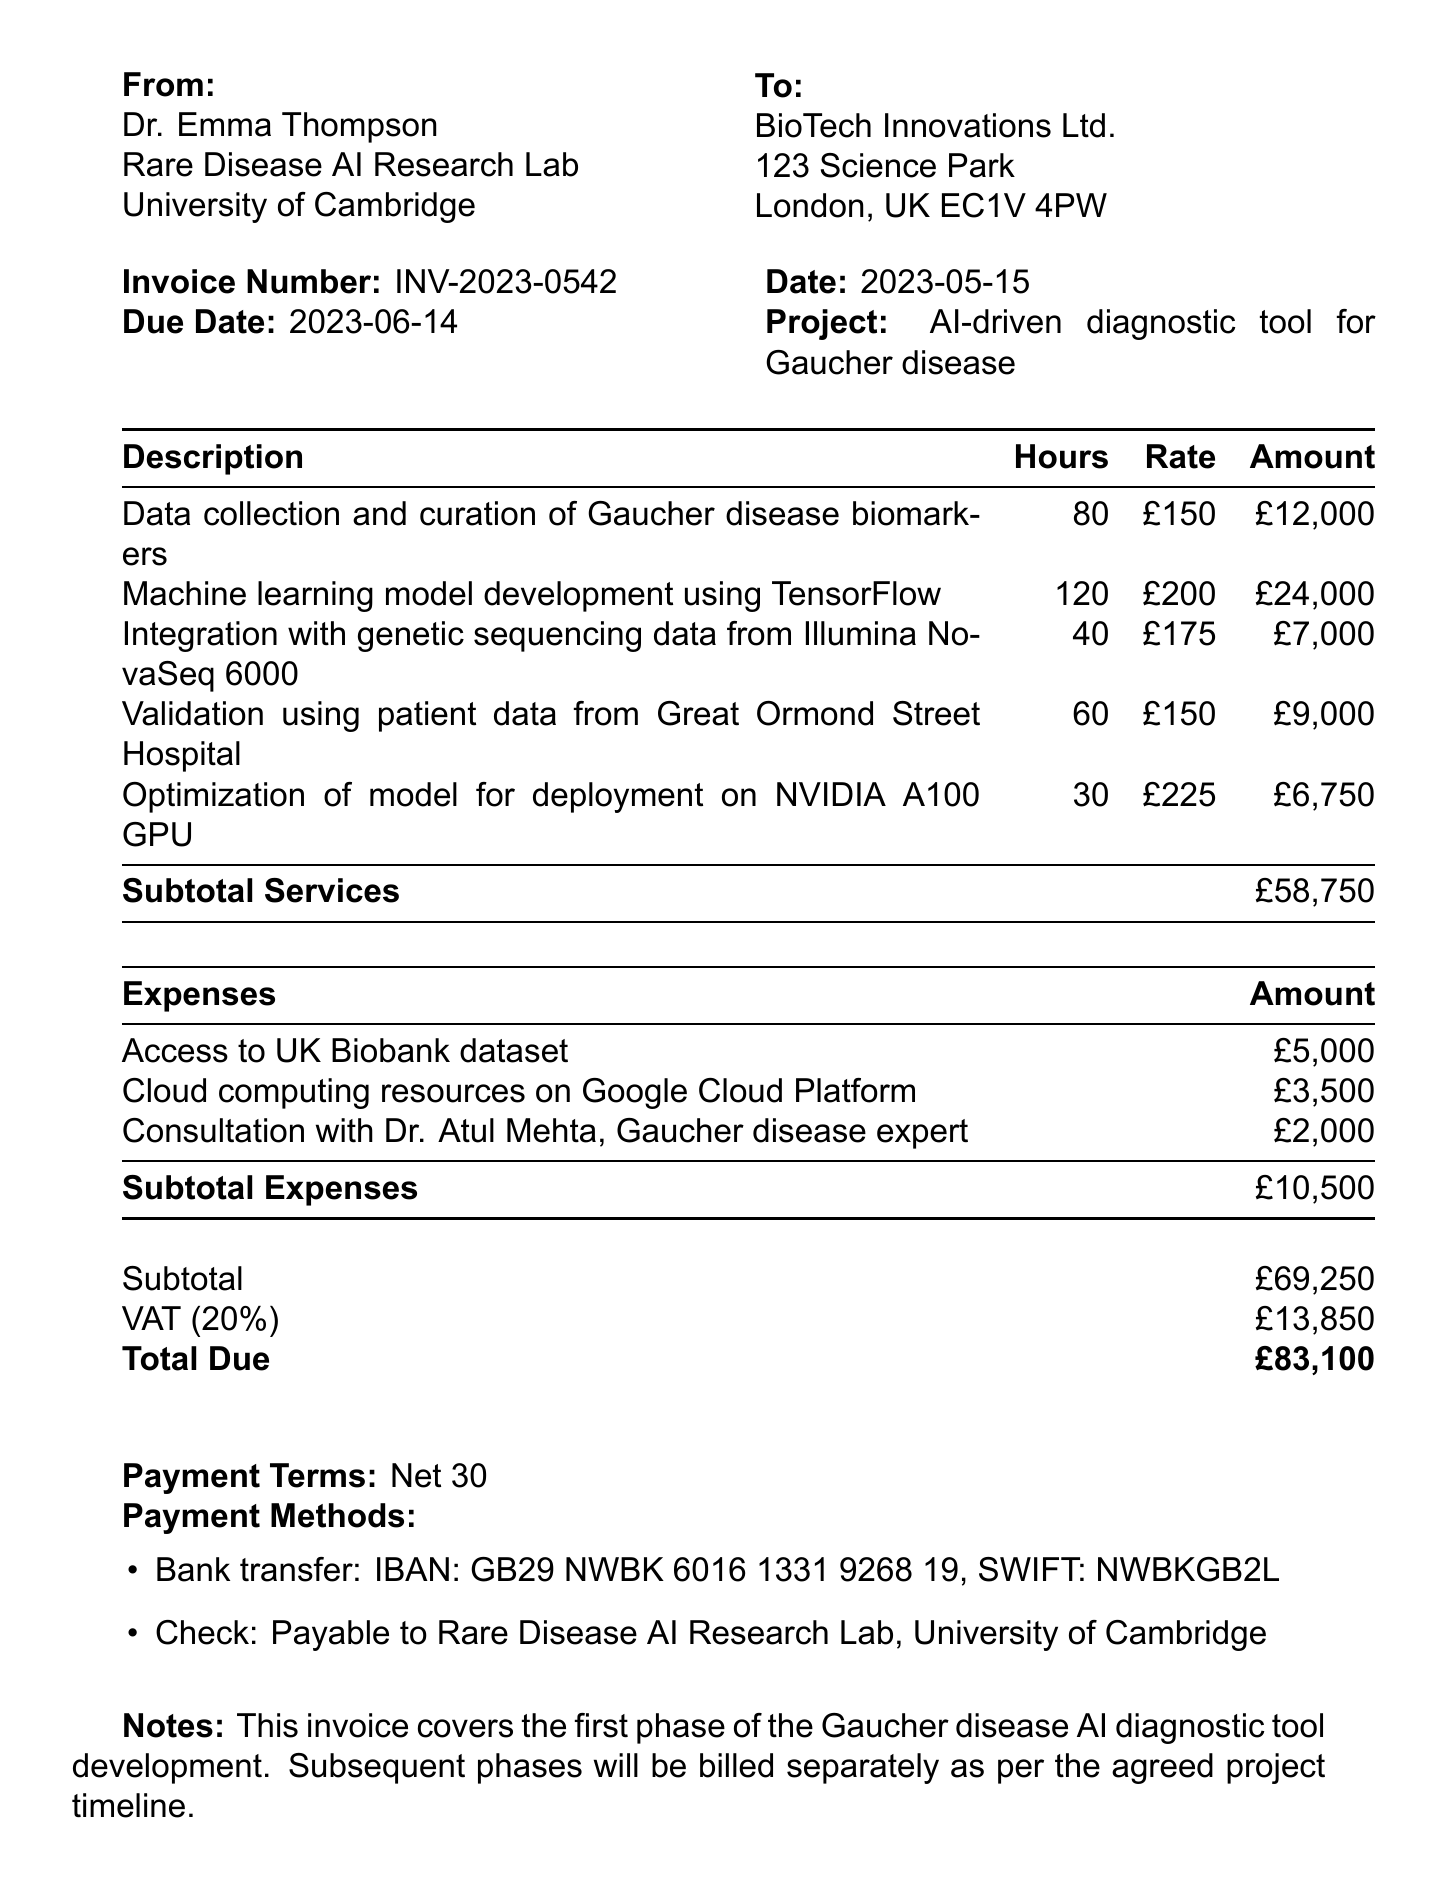What is the invoice number? The invoice number is provided in the document under invoice details.
Answer: INV-2023-0542 Who is the researcher affiliated with? The researcher is affiliated with the Rare Disease AI Research Lab at the University of Cambridge.
Answer: Rare Disease AI Research Lab, University of Cambridge What project is this invoice for? The project description is specified to give context about the services billed.
Answer: Development of AI-driven diagnostic tool for Gaucher disease How much was charged for machine learning model development? This amount can be found under the services section detailing work performed.
Answer: £24,000 What is the total amount due? The total due is calculated by adding the subtotal and taxes as noted in the document.
Answer: £83,100 How many hours were allocated for data collection and curation? This information is recorded in the services table of the invoice.
Answer: 80 What is the tax rate applied to this invoice? The tax rate is specifically mentioned in the tax section of the document.
Answer: 20% What is the payment term specified? This term is included at the end of the invoice document.
Answer: Net 30 How much was spent on consultation with Dr. Atul Mehta? The specific amount for this expense can be found in the expenses table.
Answer: £2,000 